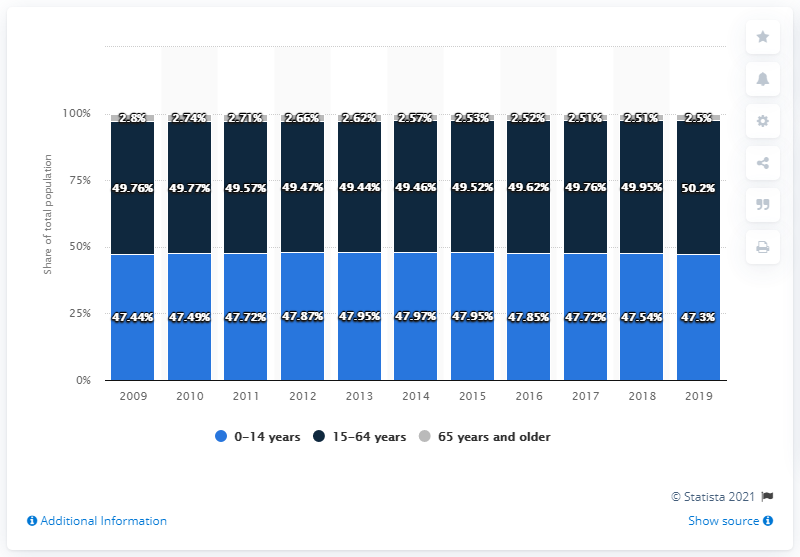Give some essential details in this illustration. The value of the gray bar has been 2.51 for how many years? 2... In 2012, the share of the 0-14 age group in the total population was 47.87%. 